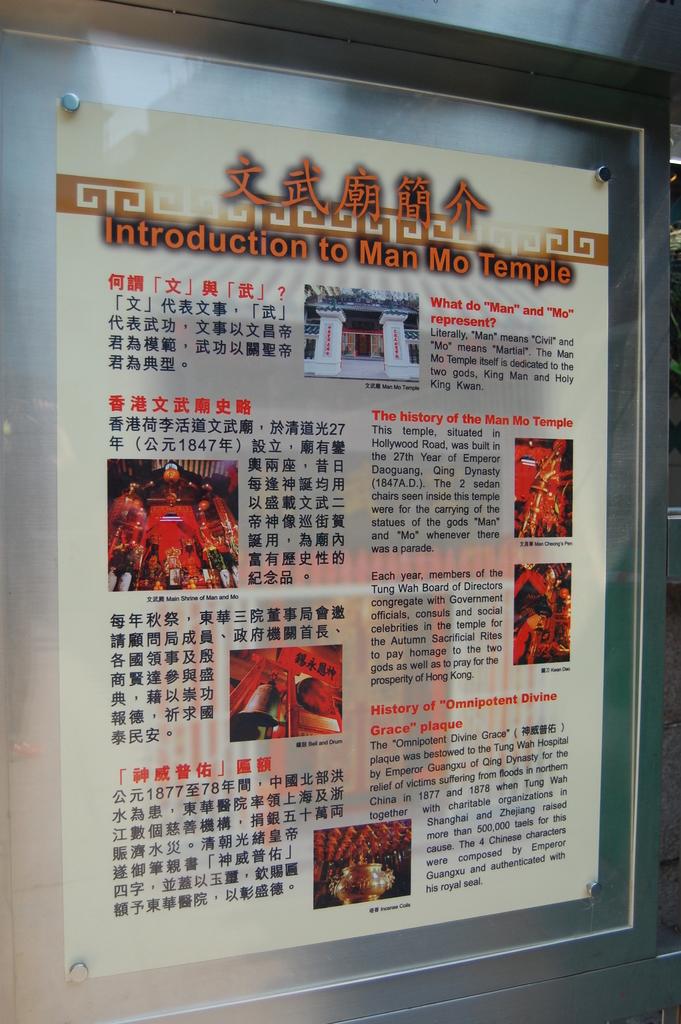Where is man mo temple?
Your answer should be compact. Hollywood road. In what year was the temple built?
Offer a very short reply. 1847. 